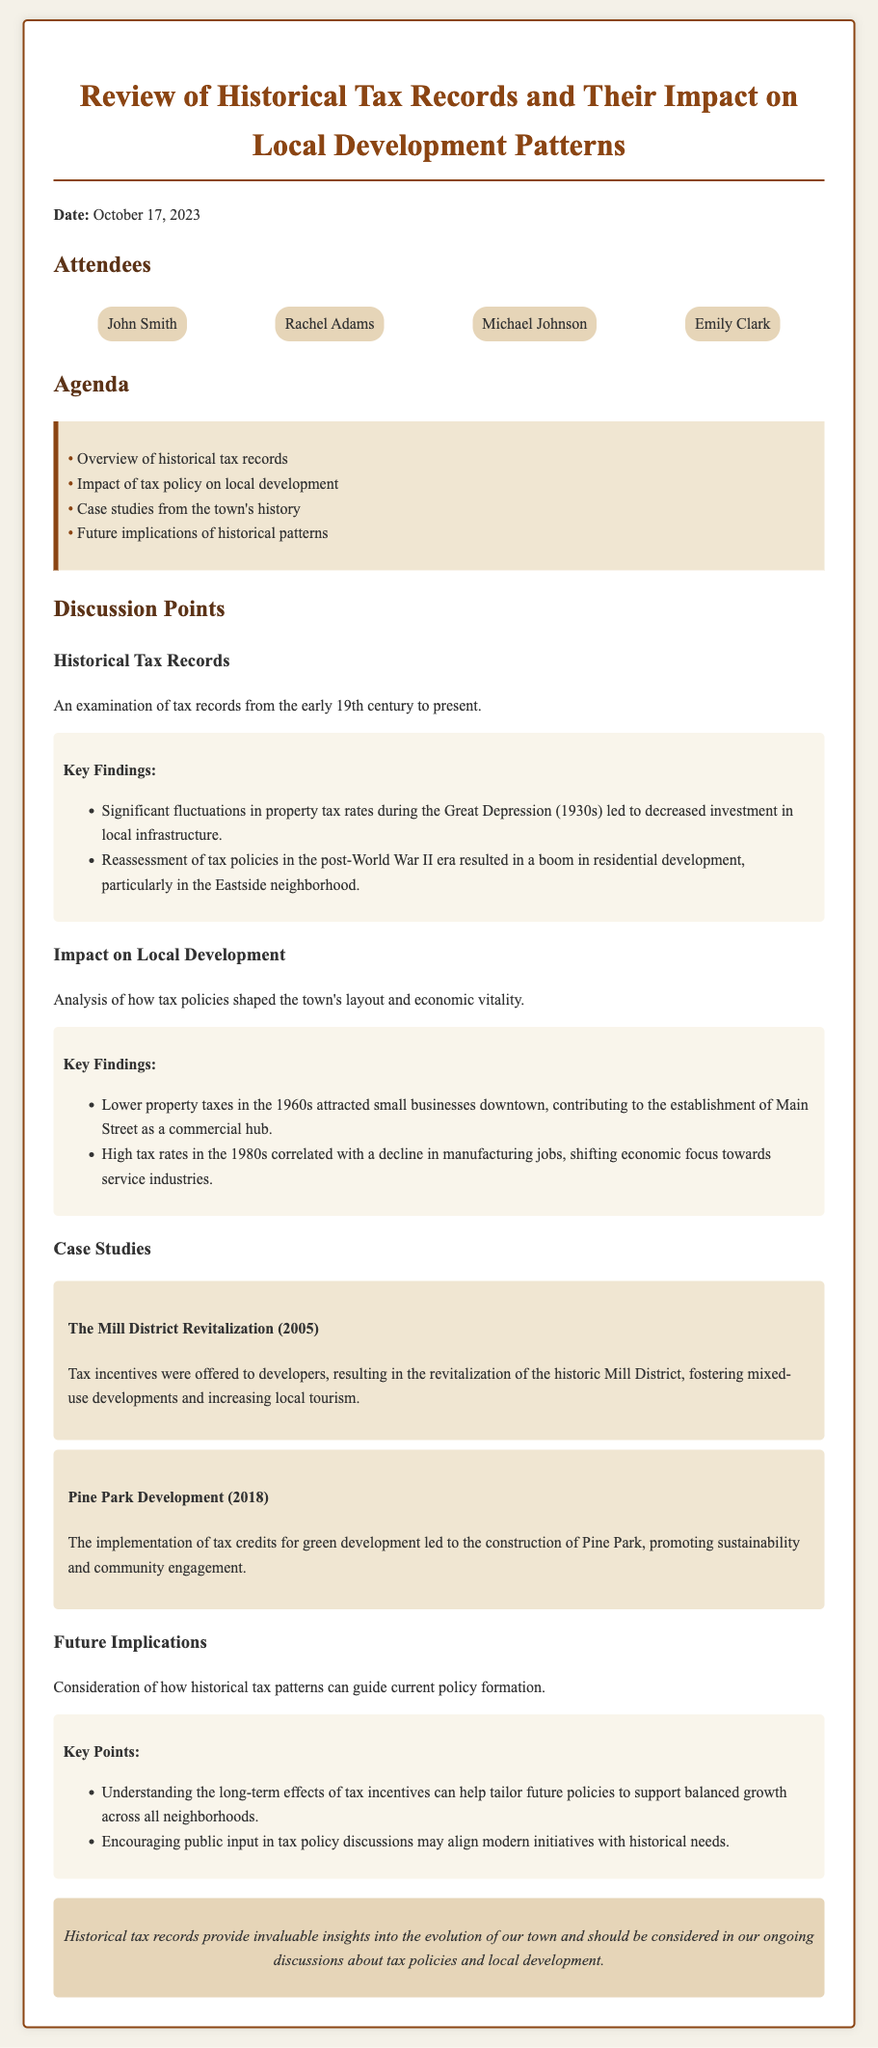What is the date of the meeting? The date of the meeting is specified in the document as October 17, 2023.
Answer: October 17, 2023 Who was one of the attendees? The document lists attendees, and one of them is John Smith.
Answer: John Smith What was one key finding related to the Great Depression? The document mentions significant fluctuations in property tax rates during the Great Depression, leading to decreased investment in local infrastructure.
Answer: Decreased investment in local infrastructure What case study is related to the year 2005? The document describes a case study on the Mill District Revitalization which occurred in 2005.
Answer: The Mill District Revitalization How did property taxes in the 1960s influence small businesses? The document states that lower property taxes in the 1960s attracted small businesses downtown, contributing to the establishment of Main Street as a commercial hub.
Answer: Establishment of Main Street as a commercial hub What is one implication discussed for future tax policy? Understanding the long-term effects of tax incentives can help tailor future policies to support balanced growth across all neighborhoods.
Answer: Tailor future policies to support balanced growth What type of document is this? This document is a set of meeting minutes focusing on the review of historical tax records and their impact on local development patterns.
Answer: Meeting minutes What theme is analyzed regarding tax policies? The impact of tax policies on local development is a major theme analyzed in the discussion points.
Answer: Impact of tax policies on local development 